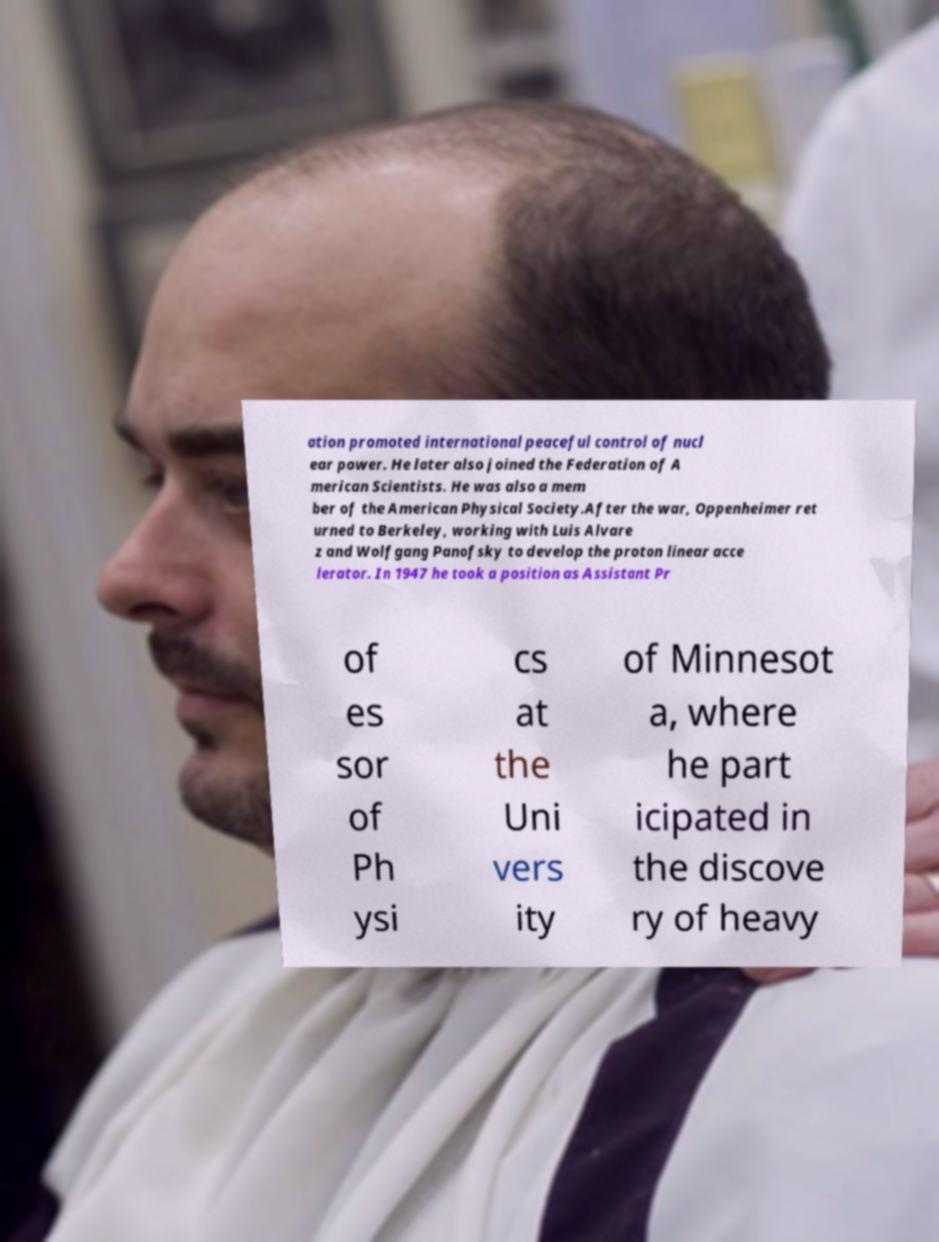For documentation purposes, I need the text within this image transcribed. Could you provide that? ation promoted international peaceful control of nucl ear power. He later also joined the Federation of A merican Scientists. He was also a mem ber of the American Physical Society.After the war, Oppenheimer ret urned to Berkeley, working with Luis Alvare z and Wolfgang Panofsky to develop the proton linear acce lerator. In 1947 he took a position as Assistant Pr of es sor of Ph ysi cs at the Uni vers ity of Minnesot a, where he part icipated in the discove ry of heavy 